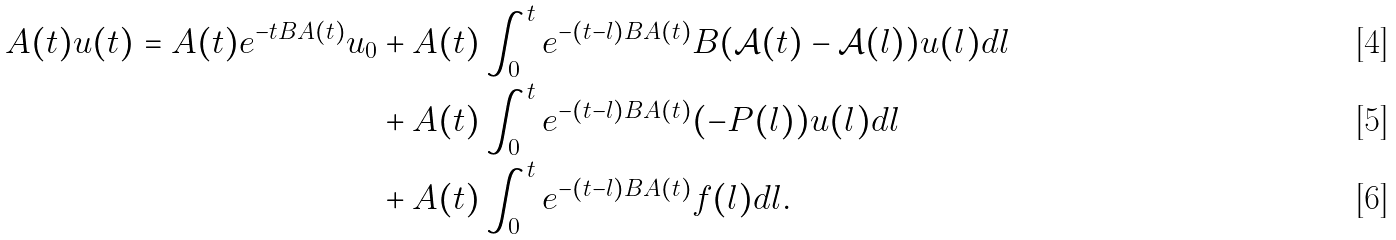Convert formula to latex. <formula><loc_0><loc_0><loc_500><loc_500>A ( t ) u ( t ) = A ( t ) e ^ { - t B A ( t ) } u _ { 0 } & + A ( t ) \int _ { 0 } ^ { t } { e ^ { - ( t - l ) B A ( t ) } B ( \mathcal { A } ( t ) - \mathcal { A } ( l ) ) u ( l ) d l } \\ & + A ( t ) \int _ { 0 } ^ { t } { e ^ { - ( t - l ) B A ( t ) } ( - P ( l ) ) u ( l ) d l } \\ & + A ( t ) \int _ { 0 } ^ { t } { e ^ { - ( t - l ) B A ( t ) } f ( l ) } d l .</formula> 